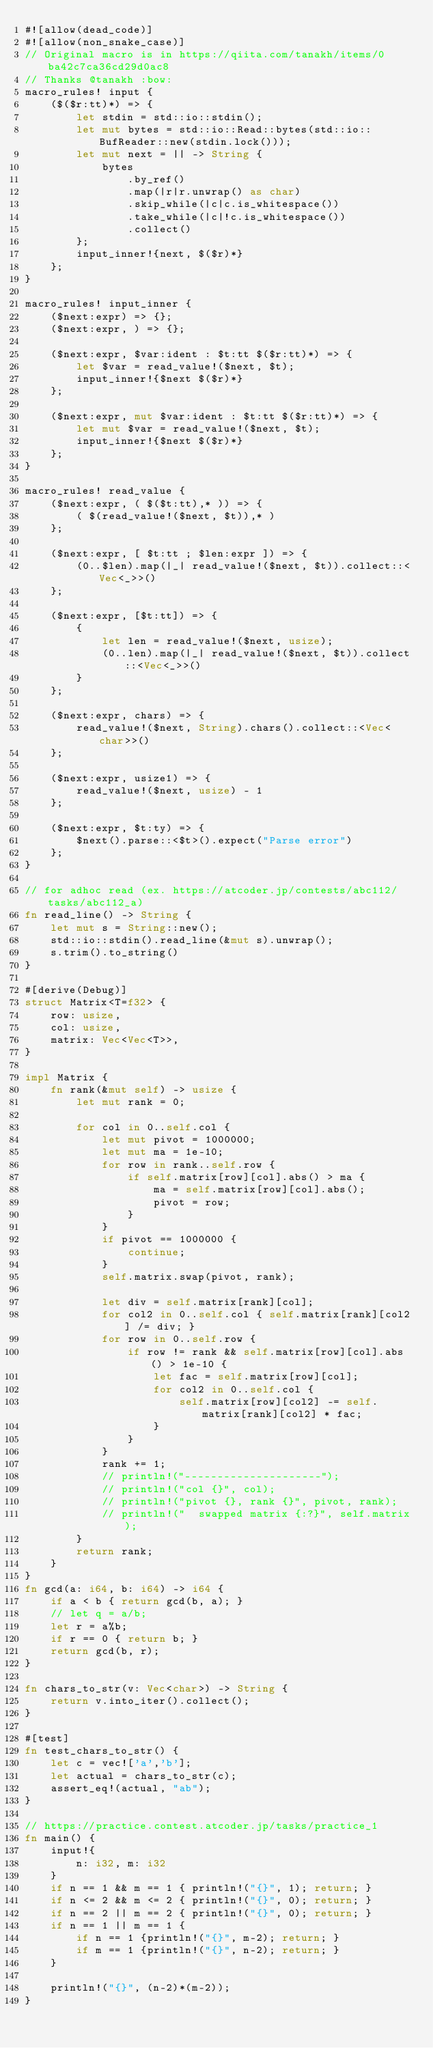Convert code to text. <code><loc_0><loc_0><loc_500><loc_500><_Rust_>#![allow(dead_code)]
#![allow(non_snake_case)]
// Original macro is in https://qiita.com/tanakh/items/0ba42c7ca36cd29d0ac8
// Thanks @tanakh :bow:
macro_rules! input {
    ($($r:tt)*) => {
        let stdin = std::io::stdin();
        let mut bytes = std::io::Read::bytes(std::io::BufReader::new(stdin.lock()));
        let mut next = || -> String {
            bytes
                .by_ref()
                .map(|r|r.unwrap() as char)
                .skip_while(|c|c.is_whitespace())
                .take_while(|c|!c.is_whitespace())
                .collect()
        };
        input_inner!{next, $($r)*}
    };
}
 
macro_rules! input_inner {
    ($next:expr) => {};
    ($next:expr, ) => {};
 
    ($next:expr, $var:ident : $t:tt $($r:tt)*) => {
        let $var = read_value!($next, $t);
        input_inner!{$next $($r)*}
    };
    
    ($next:expr, mut $var:ident : $t:tt $($r:tt)*) => {
        let mut $var = read_value!($next, $t);
        input_inner!{$next $($r)*}
    };
}
 
macro_rules! read_value {
    ($next:expr, ( $($t:tt),* )) => {
        ( $(read_value!($next, $t)),* )
    };
 
    ($next:expr, [ $t:tt ; $len:expr ]) => {
        (0..$len).map(|_| read_value!($next, $t)).collect::<Vec<_>>()
    };

    ($next:expr, [$t:tt]) => {
        {
            let len = read_value!($next, usize);
            (0..len).map(|_| read_value!($next, $t)).collect::<Vec<_>>()
        }
    };
 
    ($next:expr, chars) => {
        read_value!($next, String).chars().collect::<Vec<char>>()
    };
 
    ($next:expr, usize1) => {
        read_value!($next, usize) - 1
    };
 
    ($next:expr, $t:ty) => {
        $next().parse::<$t>().expect("Parse error")
    };
}

// for adhoc read (ex. https://atcoder.jp/contests/abc112/tasks/abc112_a)
fn read_line() -> String {
    let mut s = String::new();
    std::io::stdin().read_line(&mut s).unwrap();
    s.trim().to_string()
}

#[derive(Debug)]
struct Matrix<T=f32> {
    row: usize,
    col: usize,
    matrix: Vec<Vec<T>>,
}

impl Matrix {
    fn rank(&mut self) -> usize {
        let mut rank = 0;

        for col in 0..self.col {
            let mut pivot = 1000000;
            let mut ma = 1e-10;
            for row in rank..self.row {
                if self.matrix[row][col].abs() > ma {
                    ma = self.matrix[row][col].abs();
                    pivot = row;
                }
            }
            if pivot == 1000000 {
                continue;
            }
            self.matrix.swap(pivot, rank);

            let div = self.matrix[rank][col];
            for col2 in 0..self.col { self.matrix[rank][col2] /= div; }
            for row in 0..self.row {
                if row != rank && self.matrix[row][col].abs() > 1e-10 {
                    let fac = self.matrix[row][col];
                    for col2 in 0..self.col {
                        self.matrix[row][col2] -= self.matrix[rank][col2] * fac;
                    }
                }
            }
            rank += 1;
            // println!("---------------------");
            // println!("col {}", col);
            // println!("pivot {}, rank {}", pivot, rank);
            // println!("  swapped matrix {:?}", self.matrix);
        }
        return rank;
    }
}
fn gcd(a: i64, b: i64) -> i64 {
    if a < b { return gcd(b, a); }
    // let q = a/b;
    let r = a%b;
    if r == 0 { return b; }
    return gcd(b, r);
}

fn chars_to_str(v: Vec<char>) -> String {
    return v.into_iter().collect();
}

#[test]
fn test_chars_to_str() {
    let c = vec!['a','b'];
    let actual = chars_to_str(c);
    assert_eq!(actual, "ab");
}

// https://practice.contest.atcoder.jp/tasks/practice_1
fn main() {
    input!{
        n: i32, m: i32
    }
    if n == 1 && m == 1 { println!("{}", 1); return; }
    if n <= 2 && m <= 2 { println!("{}", 0); return; }
    if n == 2 || m == 2 { println!("{}", 0); return; }
    if n == 1 || m == 1 { 
        if n == 1 {println!("{}", m-2); return; }
        if m == 1 {println!("{}", n-2); return; }
    }

    println!("{}", (n-2)*(m-2));
}
</code> 